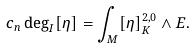Convert formula to latex. <formula><loc_0><loc_0><loc_500><loc_500>c _ { n } \deg _ { I } [ \eta ] = \int _ { M } [ \eta ] _ { K } ^ { 2 , 0 } \wedge E .</formula> 